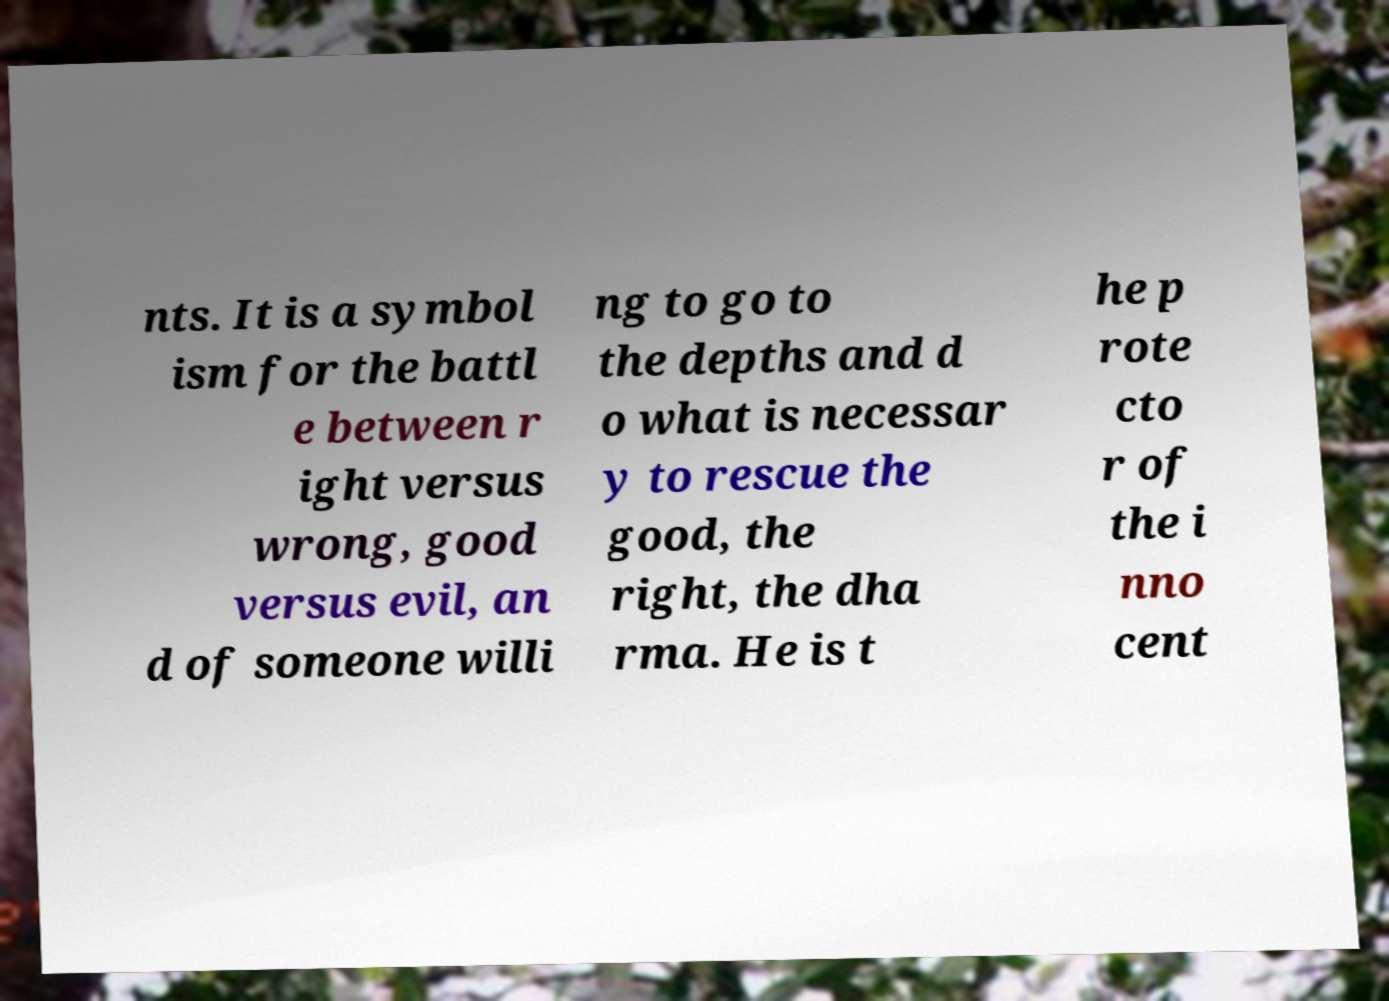Please identify and transcribe the text found in this image. nts. It is a symbol ism for the battl e between r ight versus wrong, good versus evil, an d of someone willi ng to go to the depths and d o what is necessar y to rescue the good, the right, the dha rma. He is t he p rote cto r of the i nno cent 